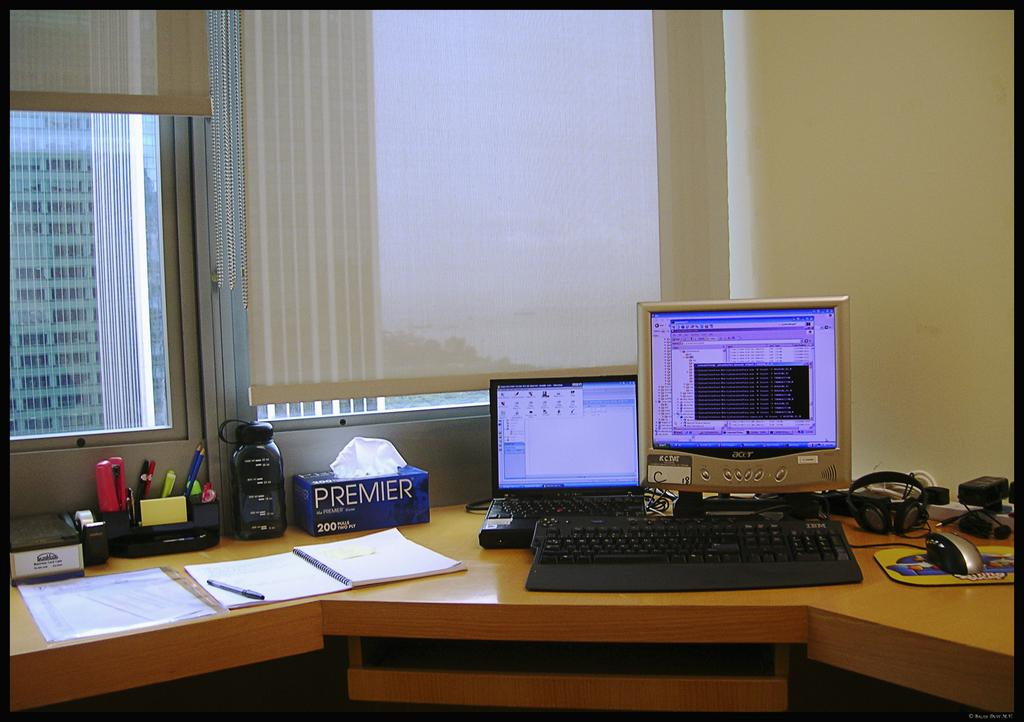What piece of furniture is present in the image? There is a table in the image. What electronic devices are on the table? There is a monitor, a laptop, a keyboard, headphones, a mouse, and a pen on the table. What other items can be seen on the table? There is a tissue box, a book, and a water bottle on the table. Can you see a crown on the table in the image? No, there is no crown present in the image. Is there a guitar on the table in the image? No, there is no guitar present in the image. 